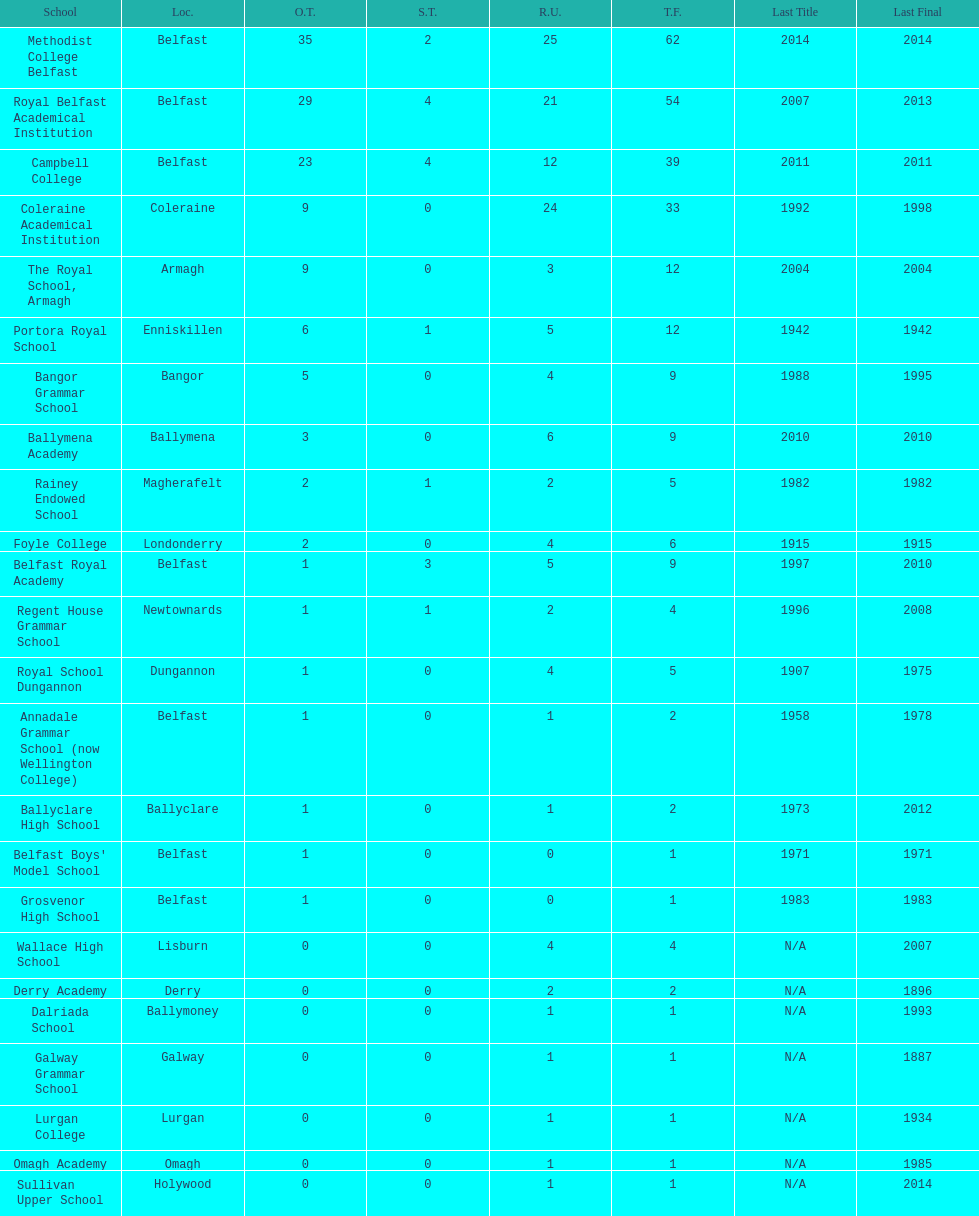How many schools had above 5 outright titles? 6. 